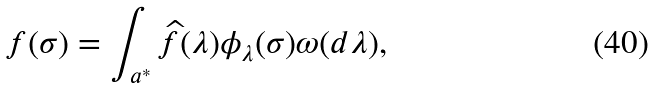<formula> <loc_0><loc_0><loc_500><loc_500>f ( \sigma ) = \int _ { a ^ { * } } \widehat { f } ( \lambda ) \phi _ { \lambda } ( \sigma ) \omega ( d \lambda ) ,</formula> 